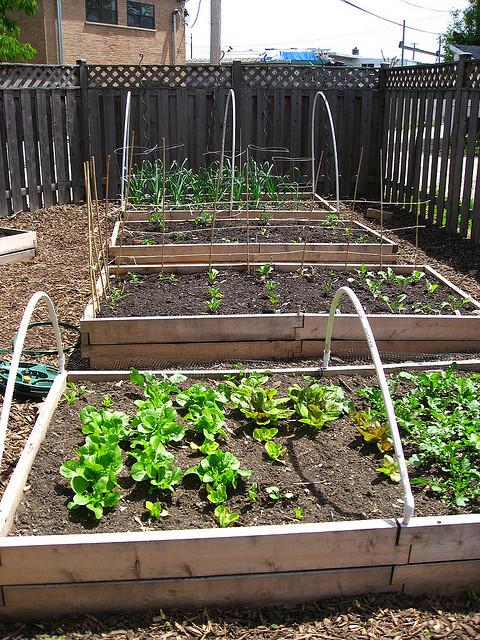Is this garden large or small?
Write a very short answer. Small. Was this photo taken outdoors?
Keep it brief. Yes. What is in the boxes?
Concise answer only. Plants. 